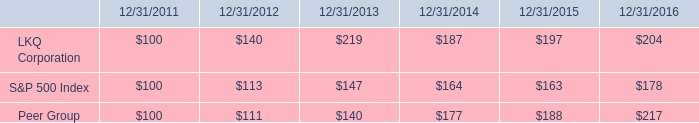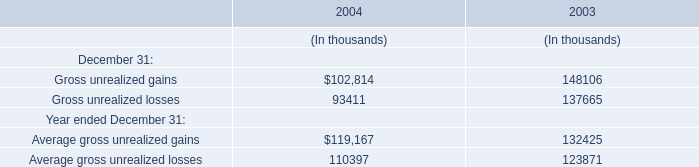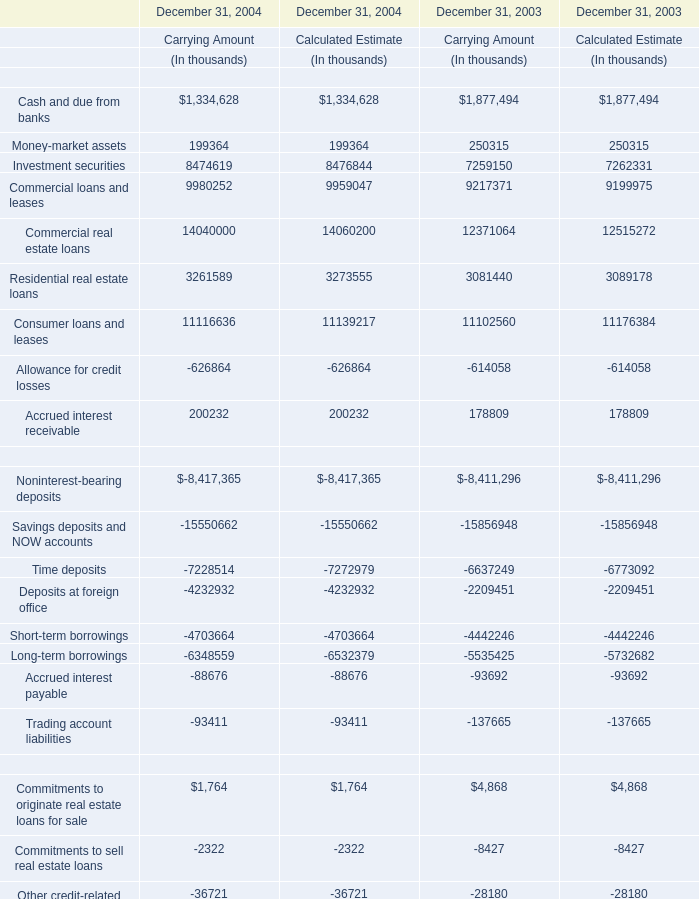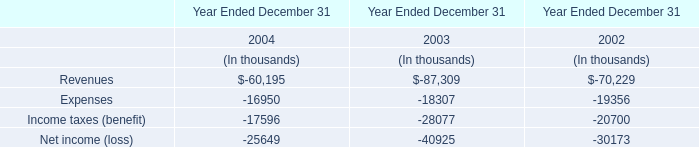What's the average of the Expenses in the years where Gross unrealized gains is positive? (in thousand) 
Computations: ((-16950 - 18307) / 2)
Answer: -17628.5. 